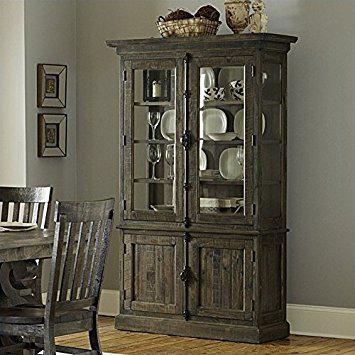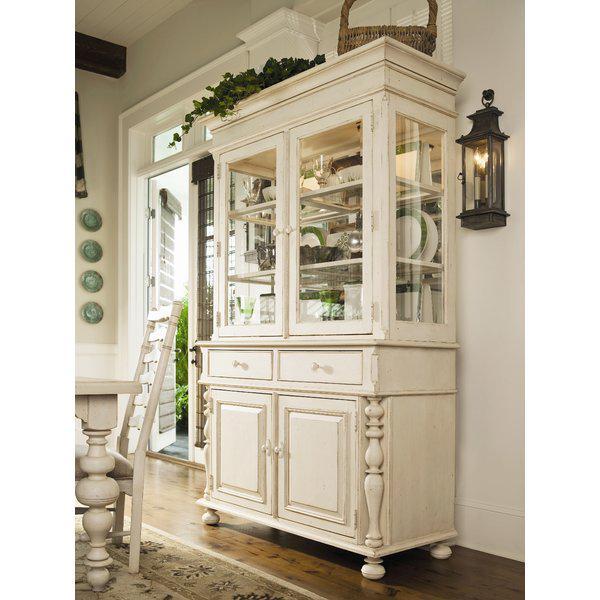The first image is the image on the left, the second image is the image on the right. Analyze the images presented: Is the assertion "Each large wooden hutch as two equal size glass doors in the upper section and two equal size solid doors in the lower section." valid? Answer yes or no. Yes. The first image is the image on the left, the second image is the image on the right. Considering the images on both sides, is "An image shows a two-door cabinet that is flat on top and has no visible feet." valid? Answer yes or no. Yes. 